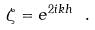<formula> <loc_0><loc_0><loc_500><loc_500>\zeta = e ^ { 2 i k h } \ .</formula> 